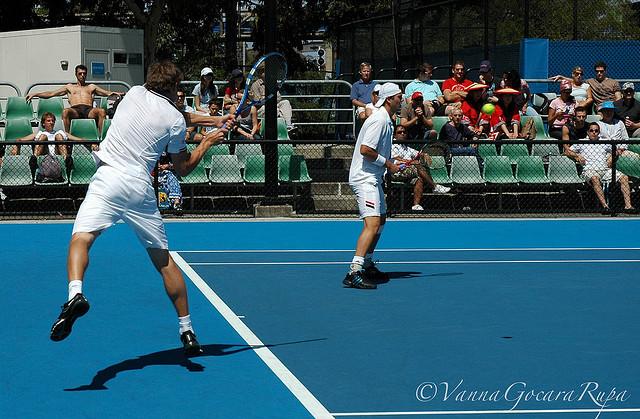How many people are wearing baseball caps?
Quick response, please. 4. How many yellow balls on the ground?
Short answer required. 0. What color of shirt is the man on the left wearing?
Quick response, please. White. Is the ball moving toward or away from the man who is jumping?
Be succinct. Away. What color is his socks?
Quick response, please. White. Are all the players female?
Write a very short answer. No. Which player just got a point?
Keep it brief. One on left. Do the players have the same color hat?
Keep it brief. No. How many people are watching the game?
Be succinct. 20. How many players are wearing hats?
Keep it brief. 1. Is this a couples match?
Concise answer only. Yes. Is this game in a stadium?
Be succinct. No. 